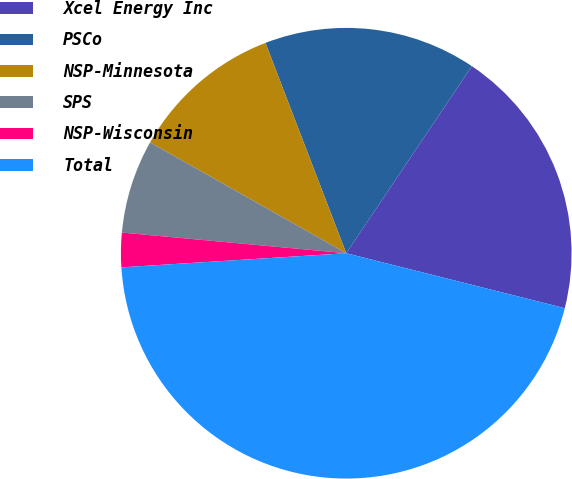Convert chart to OTSL. <chart><loc_0><loc_0><loc_500><loc_500><pie_chart><fcel>Xcel Energy Inc<fcel>PSCo<fcel>NSP-Minnesota<fcel>SPS<fcel>NSP-Wisconsin<fcel>Total<nl><fcel>19.51%<fcel>15.25%<fcel>10.98%<fcel>6.72%<fcel>2.46%<fcel>45.08%<nl></chart> 